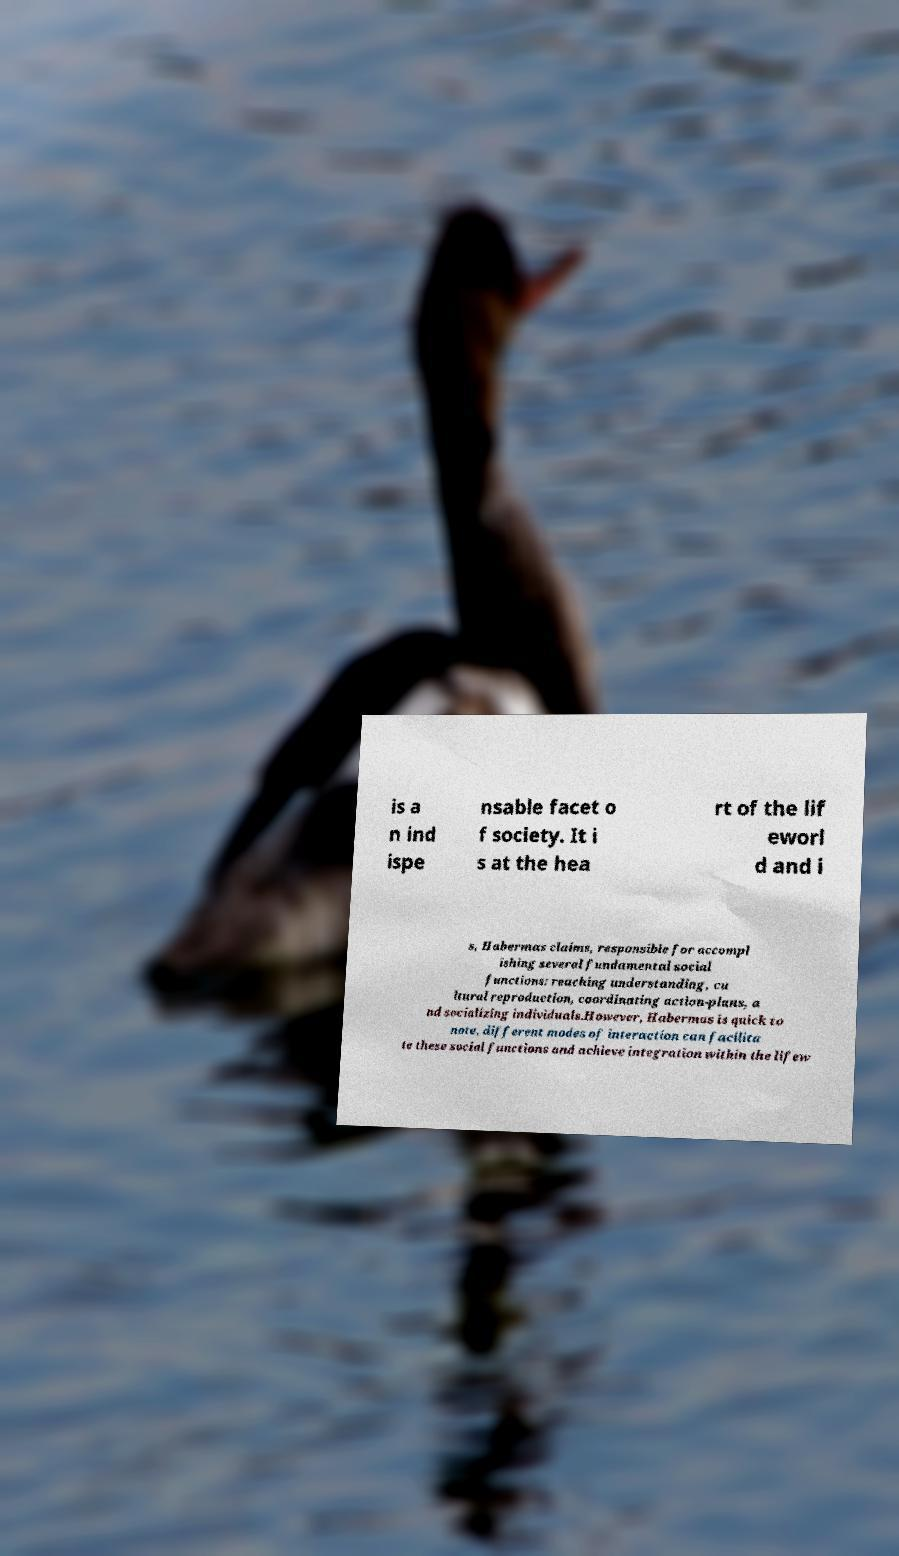Please read and relay the text visible in this image. What does it say? is a n ind ispe nsable facet o f society. It i s at the hea rt of the lif eworl d and i s, Habermas claims, responsible for accompl ishing several fundamental social functions: reaching understanding, cu ltural reproduction, coordinating action-plans, a nd socializing individuals.However, Habermas is quick to note, different modes of interaction can facilita te these social functions and achieve integration within the lifew 